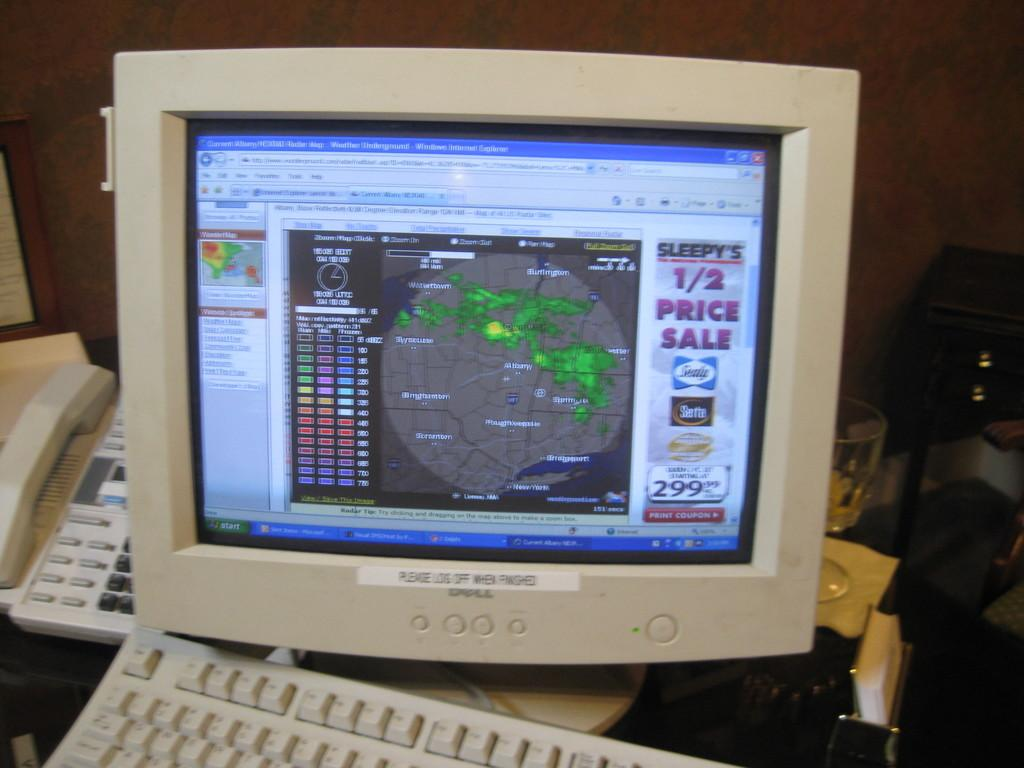<image>
Summarize the visual content of the image. One can see an advertisement for a 1/2 price sale at the side of the computer screen. 